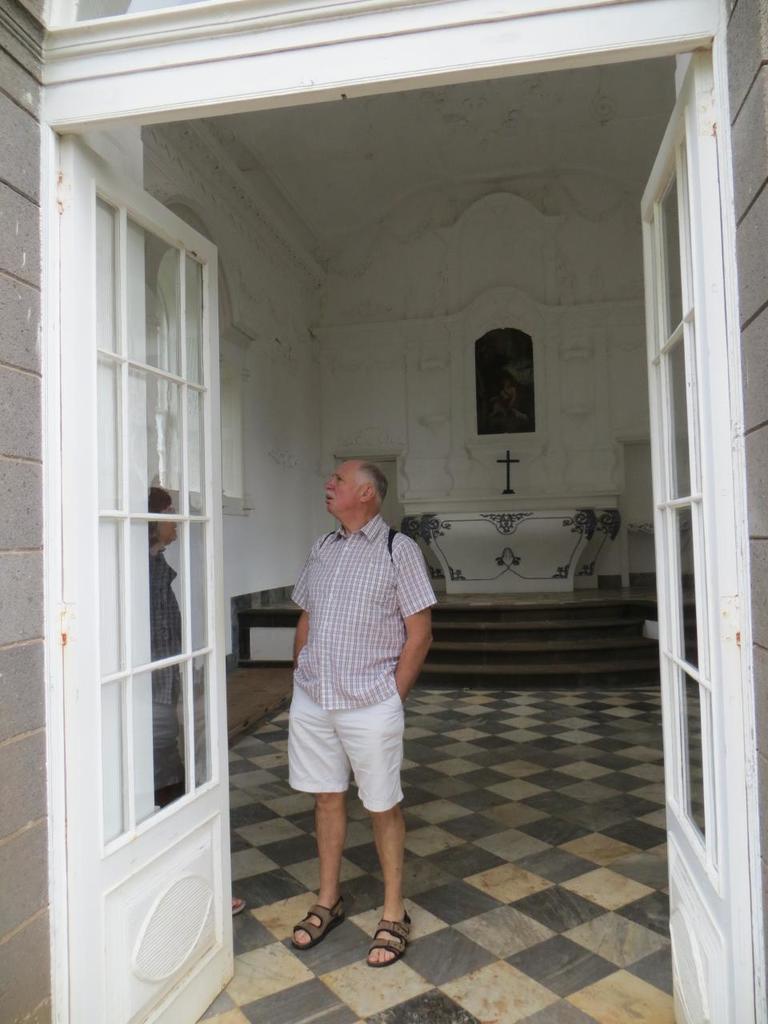Can you describe this image briefly? In the center of the image we can see persons standing on the floor. In the background we can see cross, wall, table and window. In the foreground we can see door. 